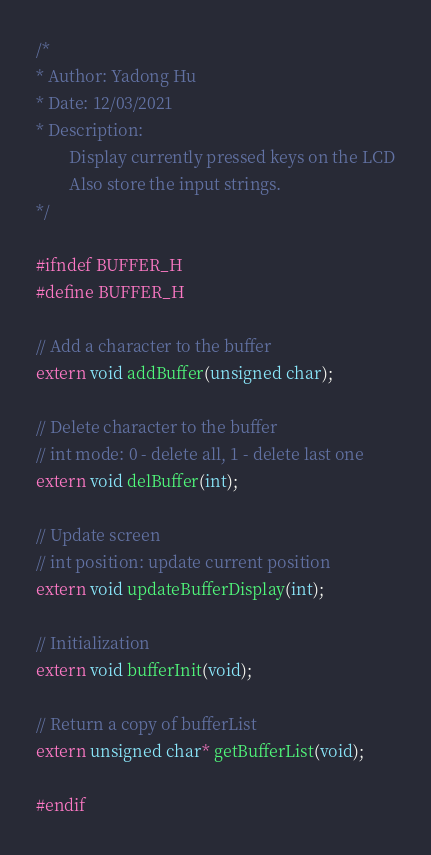Convert code to text. <code><loc_0><loc_0><loc_500><loc_500><_C_>/*
* Author: Yadong Hu
* Date: 12/03/2021
* Description:
		Display currently pressed keys on the LCD
		Also store the input strings.
*/

#ifndef BUFFER_H
#define BUFFER_H

// Add a character to the buffer
extern void addBuffer(unsigned char);

// Delete character to the buffer
// int mode: 0 - delete all, 1 - delete last one
extern void delBuffer(int);

// Update screen
// int position: update current position
extern void updateBufferDisplay(int);

// Initialization
extern void bufferInit(void);

// Return a copy of bufferList
extern unsigned char* getBufferList(void);

#endif
</code> 